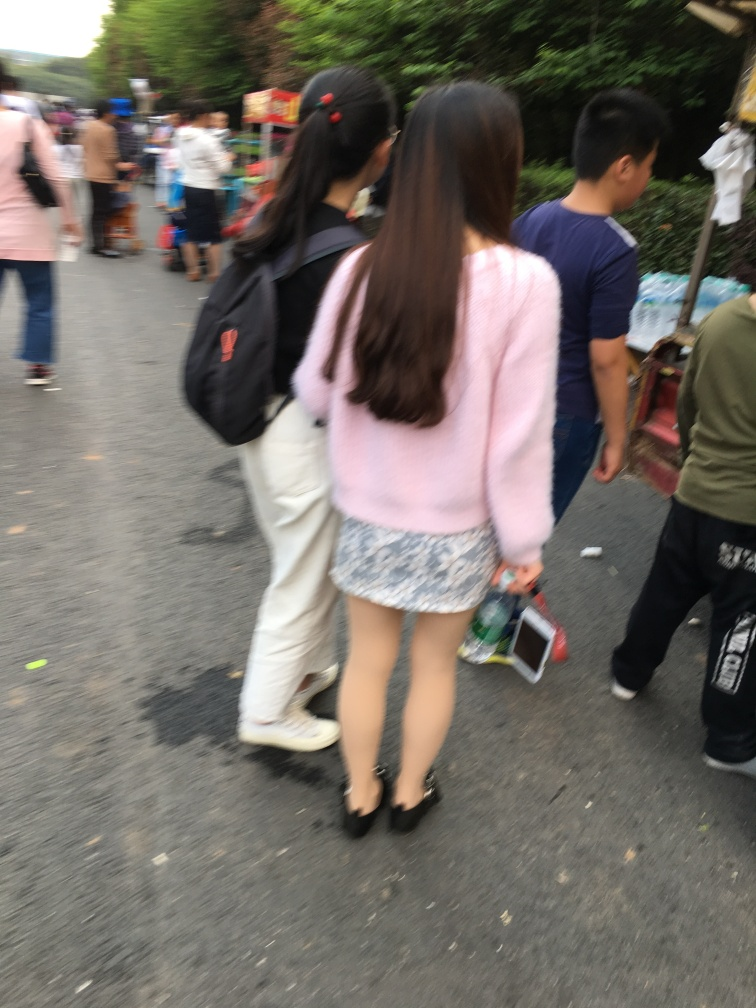Describe the fashion style shown in this image. The individuals in the image are wearing contemporary, casual clothing. Notably, one individual is wearing a pink sweater and a patterned skirt paired with black heels, representing a casual yet chic fashion sensibility suitable for a leisurely day out. 